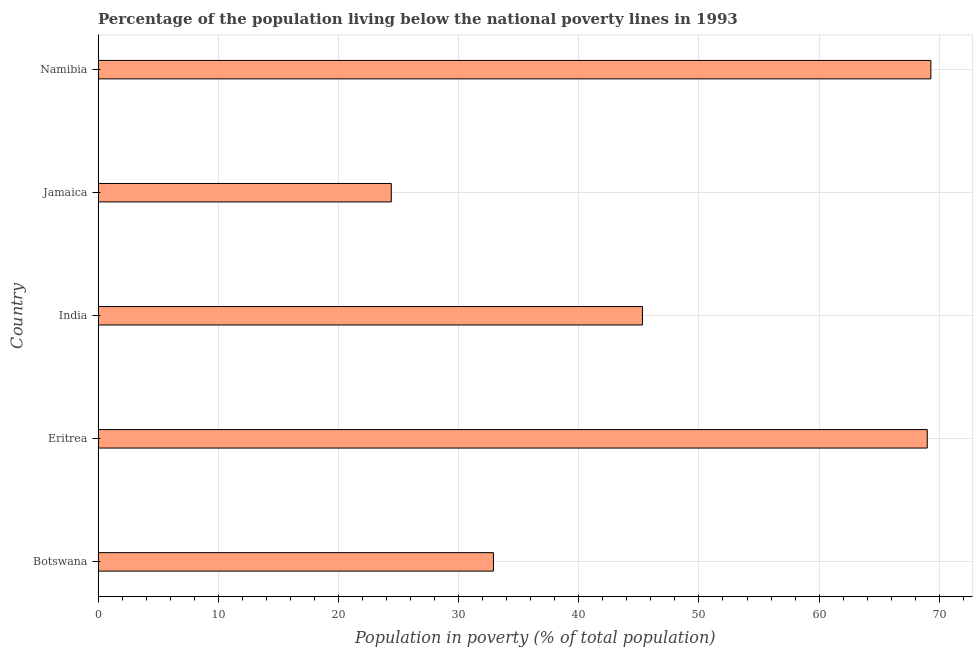What is the title of the graph?
Offer a very short reply. Percentage of the population living below the national poverty lines in 1993. What is the label or title of the X-axis?
Ensure brevity in your answer.  Population in poverty (% of total population). What is the percentage of population living below poverty line in Jamaica?
Offer a terse response. 24.4. Across all countries, what is the maximum percentage of population living below poverty line?
Make the answer very short. 69.3. Across all countries, what is the minimum percentage of population living below poverty line?
Give a very brief answer. 24.4. In which country was the percentage of population living below poverty line maximum?
Provide a succinct answer. Namibia. In which country was the percentage of population living below poverty line minimum?
Your answer should be very brief. Jamaica. What is the sum of the percentage of population living below poverty line?
Offer a very short reply. 240.9. What is the difference between the percentage of population living below poverty line in Botswana and India?
Make the answer very short. -12.4. What is the average percentage of population living below poverty line per country?
Make the answer very short. 48.18. What is the median percentage of population living below poverty line?
Your answer should be very brief. 45.3. In how many countries, is the percentage of population living below poverty line greater than 68 %?
Keep it short and to the point. 2. What is the ratio of the percentage of population living below poverty line in Eritrea to that in Jamaica?
Provide a short and direct response. 2.83. Is the percentage of population living below poverty line in Eritrea less than that in Namibia?
Your answer should be compact. Yes. What is the difference between the highest and the lowest percentage of population living below poverty line?
Your answer should be very brief. 44.9. In how many countries, is the percentage of population living below poverty line greater than the average percentage of population living below poverty line taken over all countries?
Make the answer very short. 2. Are all the bars in the graph horizontal?
Offer a terse response. Yes. How many countries are there in the graph?
Provide a succinct answer. 5. What is the difference between two consecutive major ticks on the X-axis?
Provide a short and direct response. 10. Are the values on the major ticks of X-axis written in scientific E-notation?
Offer a terse response. No. What is the Population in poverty (% of total population) of Botswana?
Ensure brevity in your answer.  32.9. What is the Population in poverty (% of total population) of Eritrea?
Your answer should be compact. 69. What is the Population in poverty (% of total population) in India?
Provide a short and direct response. 45.3. What is the Population in poverty (% of total population) in Jamaica?
Offer a terse response. 24.4. What is the Population in poverty (% of total population) in Namibia?
Your response must be concise. 69.3. What is the difference between the Population in poverty (% of total population) in Botswana and Eritrea?
Your answer should be very brief. -36.1. What is the difference between the Population in poverty (% of total population) in Botswana and India?
Ensure brevity in your answer.  -12.4. What is the difference between the Population in poverty (% of total population) in Botswana and Namibia?
Ensure brevity in your answer.  -36.4. What is the difference between the Population in poverty (% of total population) in Eritrea and India?
Your answer should be very brief. 23.7. What is the difference between the Population in poverty (% of total population) in Eritrea and Jamaica?
Keep it short and to the point. 44.6. What is the difference between the Population in poverty (% of total population) in India and Jamaica?
Your response must be concise. 20.9. What is the difference between the Population in poverty (% of total population) in India and Namibia?
Offer a terse response. -24. What is the difference between the Population in poverty (% of total population) in Jamaica and Namibia?
Offer a very short reply. -44.9. What is the ratio of the Population in poverty (% of total population) in Botswana to that in Eritrea?
Provide a succinct answer. 0.48. What is the ratio of the Population in poverty (% of total population) in Botswana to that in India?
Your answer should be very brief. 0.73. What is the ratio of the Population in poverty (% of total population) in Botswana to that in Jamaica?
Your response must be concise. 1.35. What is the ratio of the Population in poverty (% of total population) in Botswana to that in Namibia?
Keep it short and to the point. 0.47. What is the ratio of the Population in poverty (% of total population) in Eritrea to that in India?
Provide a short and direct response. 1.52. What is the ratio of the Population in poverty (% of total population) in Eritrea to that in Jamaica?
Offer a very short reply. 2.83. What is the ratio of the Population in poverty (% of total population) in Eritrea to that in Namibia?
Offer a terse response. 1. What is the ratio of the Population in poverty (% of total population) in India to that in Jamaica?
Your response must be concise. 1.86. What is the ratio of the Population in poverty (% of total population) in India to that in Namibia?
Keep it short and to the point. 0.65. What is the ratio of the Population in poverty (% of total population) in Jamaica to that in Namibia?
Keep it short and to the point. 0.35. 